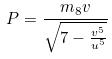Convert formula to latex. <formula><loc_0><loc_0><loc_500><loc_500>P = \frac { m _ { 8 } v } { \sqrt { 7 - \frac { v ^ { 5 } } { u ^ { 5 } } } }</formula> 